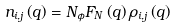Convert formula to latex. <formula><loc_0><loc_0><loc_500><loc_500>n _ { i , j } \left ( { q } \right ) = N _ { \phi } F _ { N } \left ( { q } \right ) \rho _ { i , j } \left ( { q } \right )</formula> 